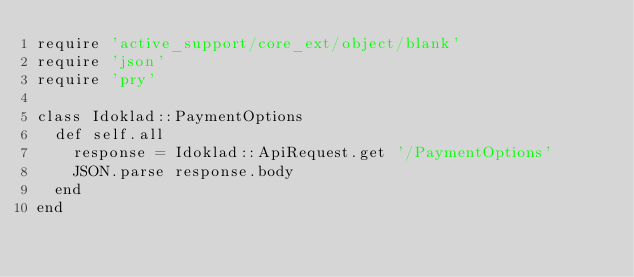<code> <loc_0><loc_0><loc_500><loc_500><_Ruby_>require 'active_support/core_ext/object/blank'
require 'json'
require 'pry'

class Idoklad::PaymentOptions
  def self.all
    response = Idoklad::ApiRequest.get '/PaymentOptions'
    JSON.parse response.body
  end
end
</code> 